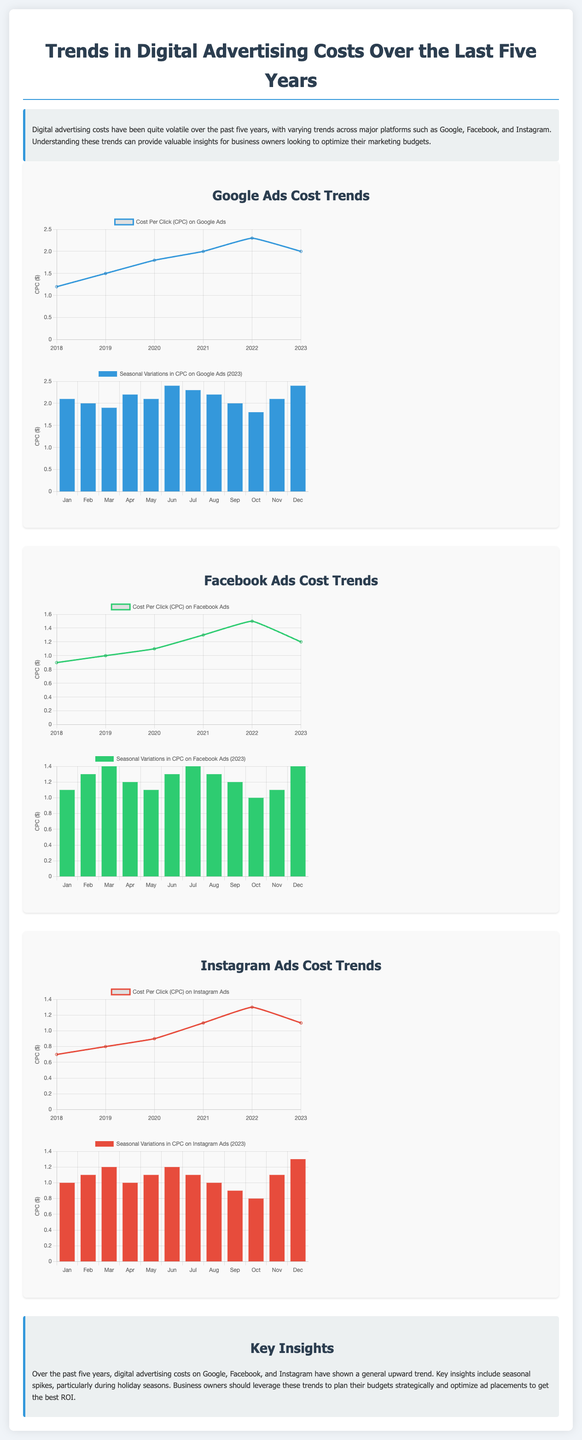What was the CPC for Google Ads in 2023? The document states that the CPC for Google Ads in 2023 is 2.0.
Answer: 2.0 What was the highest recorded CPC for Facebook Ads from 2018 to 2023? The highest recorded CPC for Facebook Ads occurred in 2022, which is 1.5.
Answer: 1.5 Which month showed the highest CPC for Google Ads in 2023? The highest CPC for Google Ads in 2023 was recorded in June at 2.4.
Answer: June What trend is observed in the CPC of Instagram Ads from 2018 to 2023? The trend indicates a general increase in CPC for Instagram Ads, peaking in 2022 with a value of 1.3 before falling to 1.1 in 2023.
Answer: Increase and then decrease Which platform had the lowest CPC in 2018? The lowest CPC in 2018 was for Instagram Ads at 0.7.
Answer: Instagram According to the heat map, what was the CPC for Facebook Ads in November 2023? The CPC for Facebook Ads in November 2023 was 1.1, as per the heat map data.
Answer: 1.1 What seasonality pattern is noted for digital advertising costs? There are seasonal spikes in digital advertising costs during holiday seasons, which is a common observation.
Answer: Seasonal spikes What color is used to represent Facebook Ads in the line chart? Facebook Ads are represented by the color green in the line chart.
Answer: Green 